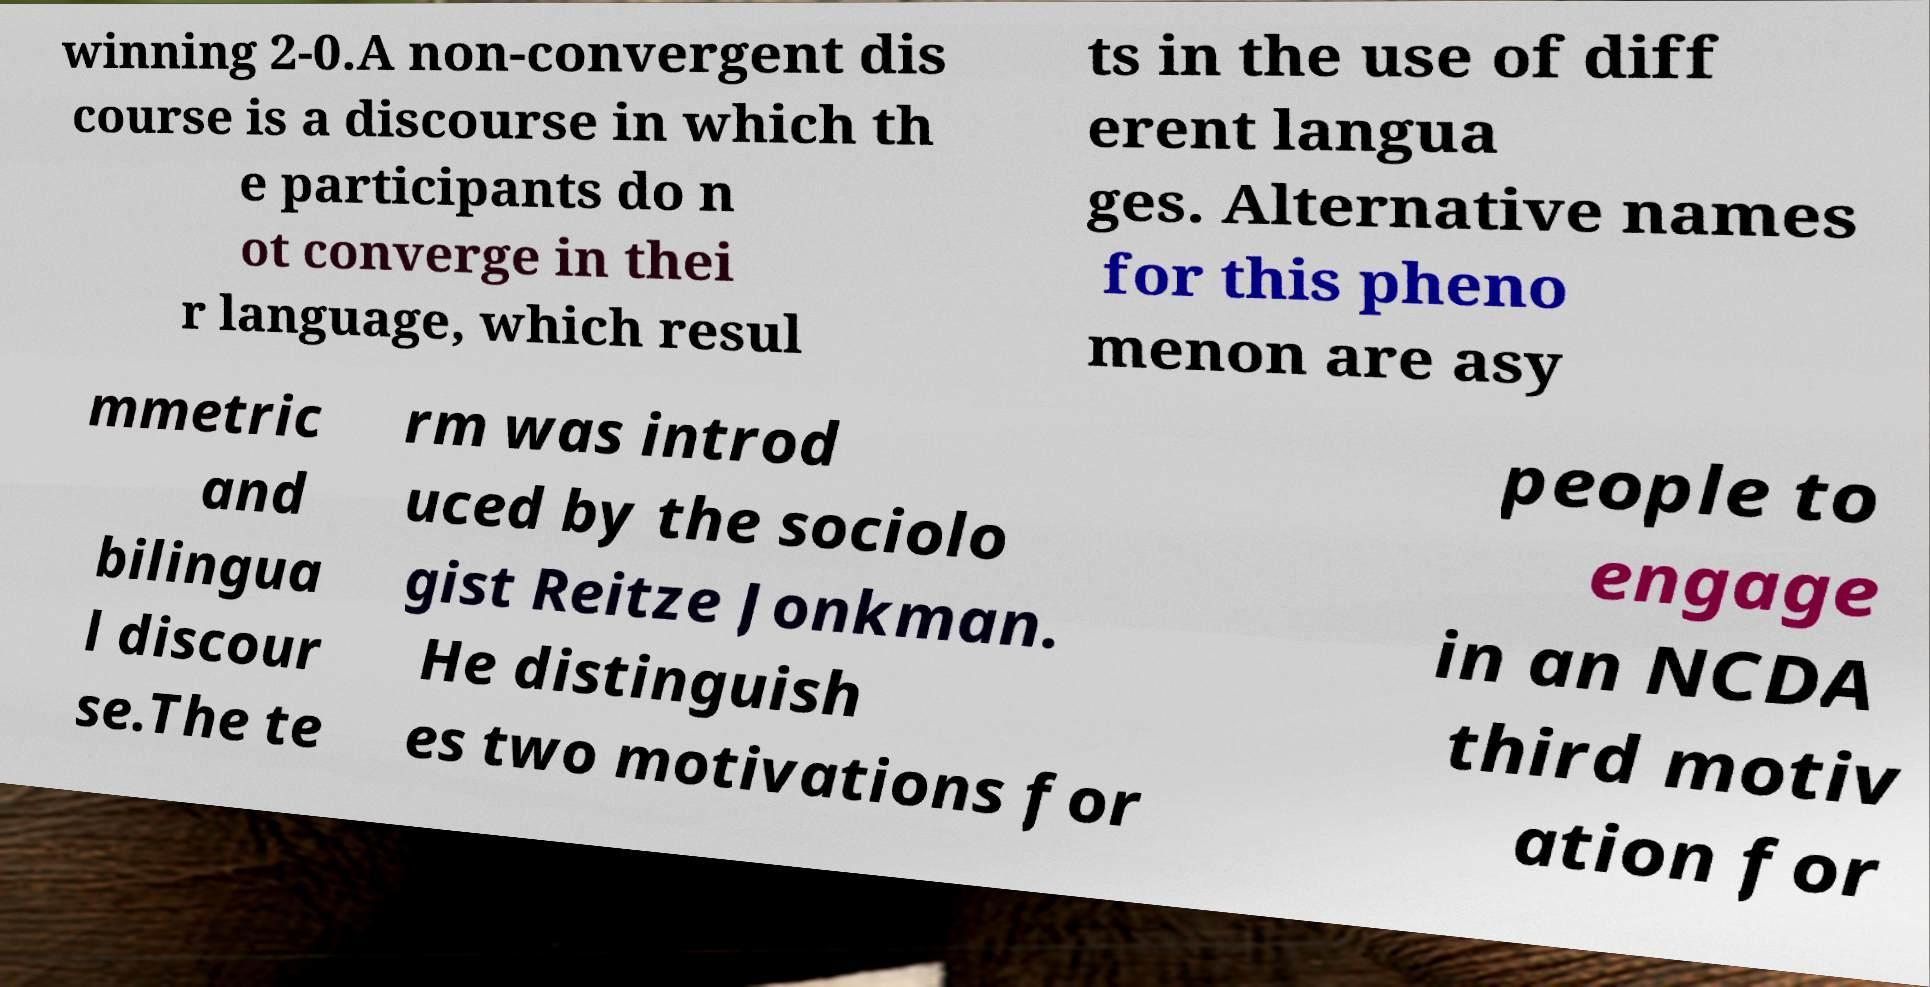For documentation purposes, I need the text within this image transcribed. Could you provide that? winning 2-0.A non-convergent dis course is a discourse in which th e participants do n ot converge in thei r language, which resul ts in the use of diff erent langua ges. Alternative names for this pheno menon are asy mmetric and bilingua l discour se.The te rm was introd uced by the sociolo gist Reitze Jonkman. He distinguish es two motivations for people to engage in an NCDA third motiv ation for 